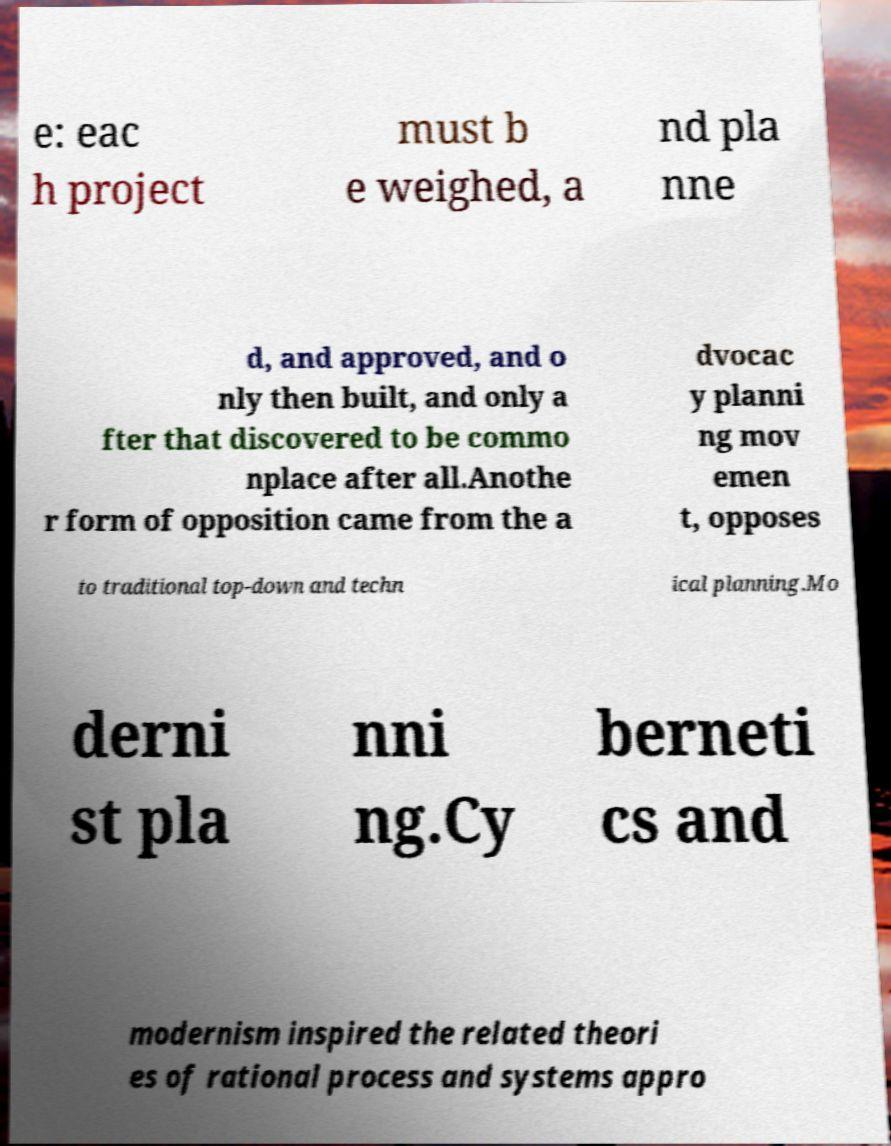I need the written content from this picture converted into text. Can you do that? e: eac h project must b e weighed, a nd pla nne d, and approved, and o nly then built, and only a fter that discovered to be commo nplace after all.Anothe r form of opposition came from the a dvocac y planni ng mov emen t, opposes to traditional top-down and techn ical planning.Mo derni st pla nni ng.Cy berneti cs and modernism inspired the related theori es of rational process and systems appro 